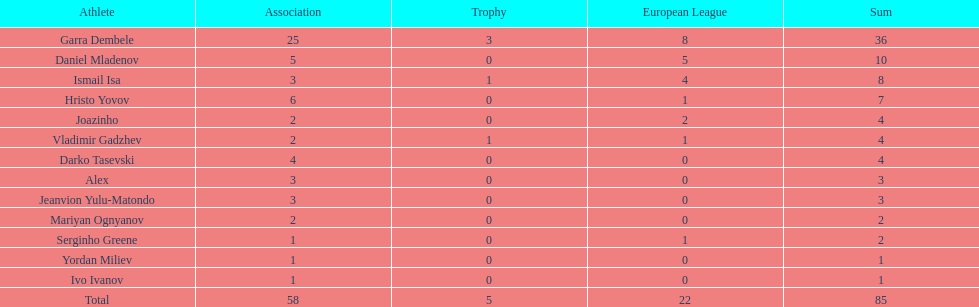In which league do joazinho and vladimir gadzhev share a player? Mariyan Ognyanov. 